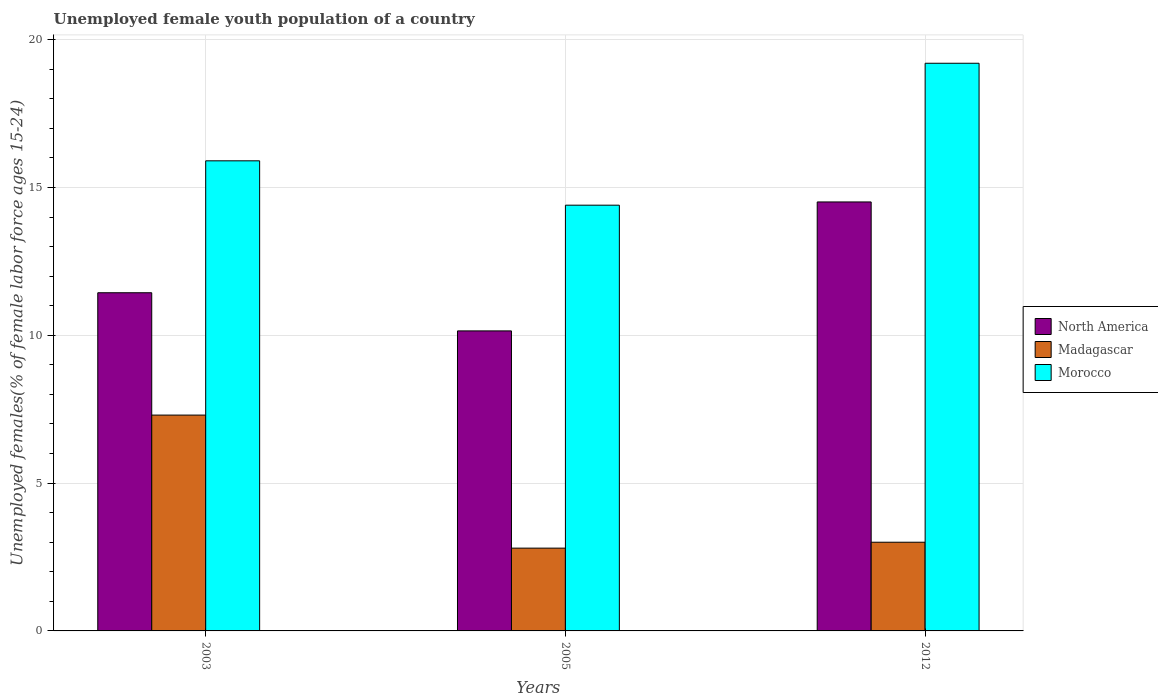What is the percentage of unemployed female youth population in North America in 2005?
Your answer should be very brief. 10.15. Across all years, what is the maximum percentage of unemployed female youth population in Madagascar?
Your answer should be compact. 7.3. Across all years, what is the minimum percentage of unemployed female youth population in Madagascar?
Make the answer very short. 2.8. In which year was the percentage of unemployed female youth population in Morocco maximum?
Provide a short and direct response. 2012. What is the total percentage of unemployed female youth population in North America in the graph?
Ensure brevity in your answer.  36.09. What is the difference between the percentage of unemployed female youth population in Madagascar in 2003 and that in 2005?
Your answer should be very brief. 4.5. What is the difference between the percentage of unemployed female youth population in North America in 2003 and the percentage of unemployed female youth population in Morocco in 2005?
Keep it short and to the point. -2.96. What is the average percentage of unemployed female youth population in Morocco per year?
Your answer should be very brief. 16.5. In the year 2012, what is the difference between the percentage of unemployed female youth population in Madagascar and percentage of unemployed female youth population in Morocco?
Make the answer very short. -16.2. In how many years, is the percentage of unemployed female youth population in North America greater than 7 %?
Give a very brief answer. 3. What is the ratio of the percentage of unemployed female youth population in Madagascar in 2005 to that in 2012?
Provide a short and direct response. 0.93. Is the difference between the percentage of unemployed female youth population in Madagascar in 2003 and 2005 greater than the difference between the percentage of unemployed female youth population in Morocco in 2003 and 2005?
Keep it short and to the point. Yes. What is the difference between the highest and the second highest percentage of unemployed female youth population in North America?
Your answer should be compact. 3.07. What is the difference between the highest and the lowest percentage of unemployed female youth population in North America?
Provide a succinct answer. 4.36. What does the 3rd bar from the left in 2012 represents?
Make the answer very short. Morocco. What does the 2nd bar from the right in 2003 represents?
Offer a very short reply. Madagascar. Is it the case that in every year, the sum of the percentage of unemployed female youth population in Morocco and percentage of unemployed female youth population in North America is greater than the percentage of unemployed female youth population in Madagascar?
Ensure brevity in your answer.  Yes. What is the difference between two consecutive major ticks on the Y-axis?
Your answer should be very brief. 5. Are the values on the major ticks of Y-axis written in scientific E-notation?
Give a very brief answer. No. Does the graph contain any zero values?
Make the answer very short. No. Does the graph contain grids?
Your answer should be compact. Yes. How many legend labels are there?
Make the answer very short. 3. How are the legend labels stacked?
Your answer should be compact. Vertical. What is the title of the graph?
Your answer should be very brief. Unemployed female youth population of a country. What is the label or title of the X-axis?
Your response must be concise. Years. What is the label or title of the Y-axis?
Provide a short and direct response. Unemployed females(% of female labor force ages 15-24). What is the Unemployed females(% of female labor force ages 15-24) in North America in 2003?
Give a very brief answer. 11.44. What is the Unemployed females(% of female labor force ages 15-24) of Madagascar in 2003?
Provide a short and direct response. 7.3. What is the Unemployed females(% of female labor force ages 15-24) in Morocco in 2003?
Your answer should be very brief. 15.9. What is the Unemployed females(% of female labor force ages 15-24) of North America in 2005?
Provide a short and direct response. 10.15. What is the Unemployed females(% of female labor force ages 15-24) of Madagascar in 2005?
Your answer should be very brief. 2.8. What is the Unemployed females(% of female labor force ages 15-24) of Morocco in 2005?
Your answer should be very brief. 14.4. What is the Unemployed females(% of female labor force ages 15-24) in North America in 2012?
Provide a short and direct response. 14.51. What is the Unemployed females(% of female labor force ages 15-24) in Madagascar in 2012?
Offer a very short reply. 3. What is the Unemployed females(% of female labor force ages 15-24) of Morocco in 2012?
Provide a succinct answer. 19.2. Across all years, what is the maximum Unemployed females(% of female labor force ages 15-24) of North America?
Offer a very short reply. 14.51. Across all years, what is the maximum Unemployed females(% of female labor force ages 15-24) of Madagascar?
Keep it short and to the point. 7.3. Across all years, what is the maximum Unemployed females(% of female labor force ages 15-24) in Morocco?
Provide a succinct answer. 19.2. Across all years, what is the minimum Unemployed females(% of female labor force ages 15-24) of North America?
Keep it short and to the point. 10.15. Across all years, what is the minimum Unemployed females(% of female labor force ages 15-24) in Madagascar?
Your answer should be compact. 2.8. Across all years, what is the minimum Unemployed females(% of female labor force ages 15-24) in Morocco?
Your response must be concise. 14.4. What is the total Unemployed females(% of female labor force ages 15-24) of North America in the graph?
Keep it short and to the point. 36.09. What is the total Unemployed females(% of female labor force ages 15-24) in Madagascar in the graph?
Make the answer very short. 13.1. What is the total Unemployed females(% of female labor force ages 15-24) in Morocco in the graph?
Your response must be concise. 49.5. What is the difference between the Unemployed females(% of female labor force ages 15-24) in North America in 2003 and that in 2005?
Your answer should be compact. 1.29. What is the difference between the Unemployed females(% of female labor force ages 15-24) of Morocco in 2003 and that in 2005?
Offer a terse response. 1.5. What is the difference between the Unemployed females(% of female labor force ages 15-24) of North America in 2003 and that in 2012?
Make the answer very short. -3.07. What is the difference between the Unemployed females(% of female labor force ages 15-24) of Morocco in 2003 and that in 2012?
Your answer should be compact. -3.3. What is the difference between the Unemployed females(% of female labor force ages 15-24) in North America in 2005 and that in 2012?
Keep it short and to the point. -4.36. What is the difference between the Unemployed females(% of female labor force ages 15-24) of Madagascar in 2005 and that in 2012?
Provide a succinct answer. -0.2. What is the difference between the Unemployed females(% of female labor force ages 15-24) of Morocco in 2005 and that in 2012?
Give a very brief answer. -4.8. What is the difference between the Unemployed females(% of female labor force ages 15-24) in North America in 2003 and the Unemployed females(% of female labor force ages 15-24) in Madagascar in 2005?
Your answer should be very brief. 8.64. What is the difference between the Unemployed females(% of female labor force ages 15-24) in North America in 2003 and the Unemployed females(% of female labor force ages 15-24) in Morocco in 2005?
Give a very brief answer. -2.96. What is the difference between the Unemployed females(% of female labor force ages 15-24) of North America in 2003 and the Unemployed females(% of female labor force ages 15-24) of Madagascar in 2012?
Provide a succinct answer. 8.44. What is the difference between the Unemployed females(% of female labor force ages 15-24) of North America in 2003 and the Unemployed females(% of female labor force ages 15-24) of Morocco in 2012?
Ensure brevity in your answer.  -7.76. What is the difference between the Unemployed females(% of female labor force ages 15-24) of Madagascar in 2003 and the Unemployed females(% of female labor force ages 15-24) of Morocco in 2012?
Provide a short and direct response. -11.9. What is the difference between the Unemployed females(% of female labor force ages 15-24) of North America in 2005 and the Unemployed females(% of female labor force ages 15-24) of Madagascar in 2012?
Your answer should be compact. 7.15. What is the difference between the Unemployed females(% of female labor force ages 15-24) of North America in 2005 and the Unemployed females(% of female labor force ages 15-24) of Morocco in 2012?
Your response must be concise. -9.05. What is the difference between the Unemployed females(% of female labor force ages 15-24) of Madagascar in 2005 and the Unemployed females(% of female labor force ages 15-24) of Morocco in 2012?
Provide a succinct answer. -16.4. What is the average Unemployed females(% of female labor force ages 15-24) in North America per year?
Provide a short and direct response. 12.03. What is the average Unemployed females(% of female labor force ages 15-24) of Madagascar per year?
Make the answer very short. 4.37. What is the average Unemployed females(% of female labor force ages 15-24) of Morocco per year?
Your response must be concise. 16.5. In the year 2003, what is the difference between the Unemployed females(% of female labor force ages 15-24) in North America and Unemployed females(% of female labor force ages 15-24) in Madagascar?
Provide a succinct answer. 4.14. In the year 2003, what is the difference between the Unemployed females(% of female labor force ages 15-24) of North America and Unemployed females(% of female labor force ages 15-24) of Morocco?
Offer a terse response. -4.46. In the year 2003, what is the difference between the Unemployed females(% of female labor force ages 15-24) in Madagascar and Unemployed females(% of female labor force ages 15-24) in Morocco?
Keep it short and to the point. -8.6. In the year 2005, what is the difference between the Unemployed females(% of female labor force ages 15-24) in North America and Unemployed females(% of female labor force ages 15-24) in Madagascar?
Offer a very short reply. 7.35. In the year 2005, what is the difference between the Unemployed females(% of female labor force ages 15-24) of North America and Unemployed females(% of female labor force ages 15-24) of Morocco?
Your answer should be very brief. -4.25. In the year 2005, what is the difference between the Unemployed females(% of female labor force ages 15-24) in Madagascar and Unemployed females(% of female labor force ages 15-24) in Morocco?
Provide a succinct answer. -11.6. In the year 2012, what is the difference between the Unemployed females(% of female labor force ages 15-24) of North America and Unemployed females(% of female labor force ages 15-24) of Madagascar?
Your answer should be compact. 11.51. In the year 2012, what is the difference between the Unemployed females(% of female labor force ages 15-24) in North America and Unemployed females(% of female labor force ages 15-24) in Morocco?
Make the answer very short. -4.69. In the year 2012, what is the difference between the Unemployed females(% of female labor force ages 15-24) of Madagascar and Unemployed females(% of female labor force ages 15-24) of Morocco?
Your response must be concise. -16.2. What is the ratio of the Unemployed females(% of female labor force ages 15-24) in North America in 2003 to that in 2005?
Provide a succinct answer. 1.13. What is the ratio of the Unemployed females(% of female labor force ages 15-24) of Madagascar in 2003 to that in 2005?
Give a very brief answer. 2.61. What is the ratio of the Unemployed females(% of female labor force ages 15-24) of Morocco in 2003 to that in 2005?
Offer a very short reply. 1.1. What is the ratio of the Unemployed females(% of female labor force ages 15-24) of North America in 2003 to that in 2012?
Your answer should be very brief. 0.79. What is the ratio of the Unemployed females(% of female labor force ages 15-24) in Madagascar in 2003 to that in 2012?
Offer a very short reply. 2.43. What is the ratio of the Unemployed females(% of female labor force ages 15-24) of Morocco in 2003 to that in 2012?
Make the answer very short. 0.83. What is the ratio of the Unemployed females(% of female labor force ages 15-24) in North America in 2005 to that in 2012?
Your answer should be compact. 0.7. What is the ratio of the Unemployed females(% of female labor force ages 15-24) of Madagascar in 2005 to that in 2012?
Your answer should be very brief. 0.93. What is the difference between the highest and the second highest Unemployed females(% of female labor force ages 15-24) in North America?
Your answer should be very brief. 3.07. What is the difference between the highest and the second highest Unemployed females(% of female labor force ages 15-24) of Madagascar?
Your response must be concise. 4.3. What is the difference between the highest and the lowest Unemployed females(% of female labor force ages 15-24) in North America?
Provide a succinct answer. 4.36. What is the difference between the highest and the lowest Unemployed females(% of female labor force ages 15-24) of Morocco?
Your answer should be compact. 4.8. 